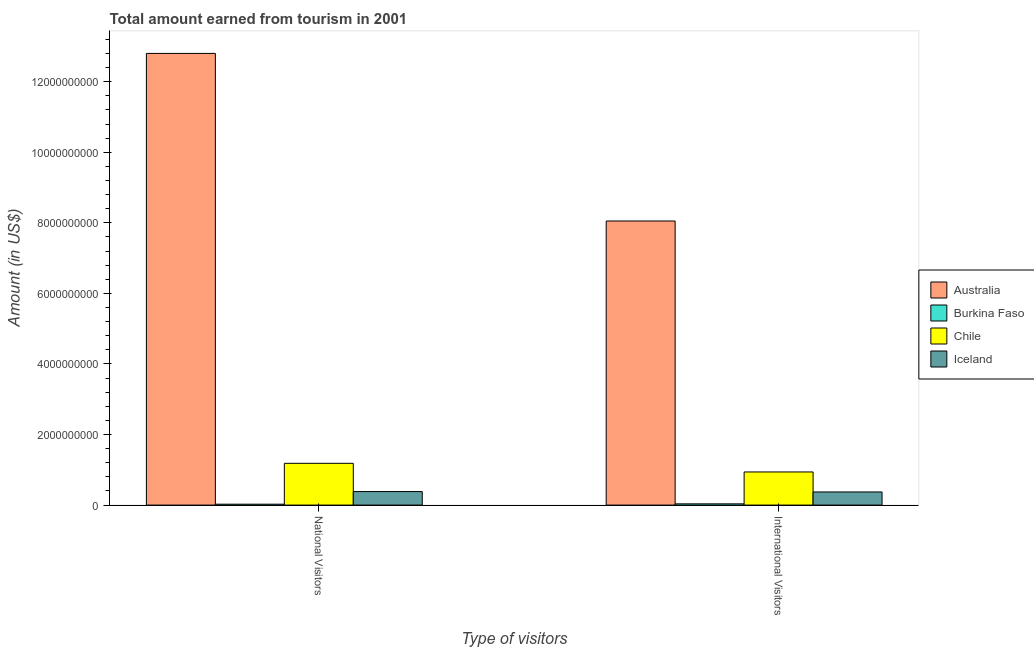Are the number of bars per tick equal to the number of legend labels?
Offer a very short reply. Yes. How many bars are there on the 1st tick from the right?
Give a very brief answer. 4. What is the label of the 1st group of bars from the left?
Keep it short and to the point. National Visitors. What is the amount earned from international visitors in Chile?
Provide a short and direct response. 9.39e+08. Across all countries, what is the maximum amount earned from international visitors?
Keep it short and to the point. 8.05e+09. Across all countries, what is the minimum amount earned from national visitors?
Offer a very short reply. 2.50e+07. In which country was the amount earned from national visitors maximum?
Make the answer very short. Australia. In which country was the amount earned from international visitors minimum?
Offer a very short reply. Burkina Faso. What is the total amount earned from national visitors in the graph?
Provide a short and direct response. 1.44e+1. What is the difference between the amount earned from national visitors in Iceland and that in Burkina Faso?
Offer a very short reply. 3.58e+08. What is the difference between the amount earned from national visitors in Iceland and the amount earned from international visitors in Australia?
Your answer should be compact. -7.67e+09. What is the average amount earned from national visitors per country?
Make the answer very short. 3.60e+09. What is the difference between the amount earned from international visitors and amount earned from national visitors in Chile?
Make the answer very short. -2.45e+08. In how many countries, is the amount earned from national visitors greater than 800000000 US$?
Your answer should be compact. 2. What is the ratio of the amount earned from national visitors in Australia to that in Iceland?
Offer a very short reply. 33.43. Is the amount earned from national visitors in Australia less than that in Iceland?
Make the answer very short. No. What does the 2nd bar from the left in National Visitors represents?
Offer a terse response. Burkina Faso. How many bars are there?
Ensure brevity in your answer.  8. How many countries are there in the graph?
Your answer should be very brief. 4. What is the difference between two consecutive major ticks on the Y-axis?
Give a very brief answer. 2.00e+09. Where does the legend appear in the graph?
Provide a succinct answer. Center right. How many legend labels are there?
Offer a very short reply. 4. What is the title of the graph?
Provide a short and direct response. Total amount earned from tourism in 2001. Does "Bangladesh" appear as one of the legend labels in the graph?
Provide a succinct answer. No. What is the label or title of the X-axis?
Provide a short and direct response. Type of visitors. What is the Amount (in US$) of Australia in National Visitors?
Your answer should be very brief. 1.28e+1. What is the Amount (in US$) of Burkina Faso in National Visitors?
Provide a succinct answer. 2.50e+07. What is the Amount (in US$) in Chile in National Visitors?
Your answer should be very brief. 1.18e+09. What is the Amount (in US$) of Iceland in National Visitors?
Offer a terse response. 3.83e+08. What is the Amount (in US$) in Australia in International Visitors?
Keep it short and to the point. 8.05e+09. What is the Amount (in US$) in Burkina Faso in International Visitors?
Your answer should be very brief. 3.50e+07. What is the Amount (in US$) in Chile in International Visitors?
Provide a succinct answer. 9.39e+08. What is the Amount (in US$) of Iceland in International Visitors?
Your answer should be compact. 3.72e+08. Across all Type of visitors, what is the maximum Amount (in US$) in Australia?
Give a very brief answer. 1.28e+1. Across all Type of visitors, what is the maximum Amount (in US$) in Burkina Faso?
Provide a succinct answer. 3.50e+07. Across all Type of visitors, what is the maximum Amount (in US$) in Chile?
Provide a short and direct response. 1.18e+09. Across all Type of visitors, what is the maximum Amount (in US$) of Iceland?
Offer a very short reply. 3.83e+08. Across all Type of visitors, what is the minimum Amount (in US$) in Australia?
Ensure brevity in your answer.  8.05e+09. Across all Type of visitors, what is the minimum Amount (in US$) of Burkina Faso?
Offer a terse response. 2.50e+07. Across all Type of visitors, what is the minimum Amount (in US$) of Chile?
Provide a short and direct response. 9.39e+08. Across all Type of visitors, what is the minimum Amount (in US$) in Iceland?
Your answer should be compact. 3.72e+08. What is the total Amount (in US$) in Australia in the graph?
Your answer should be compact. 2.09e+1. What is the total Amount (in US$) in Burkina Faso in the graph?
Keep it short and to the point. 6.00e+07. What is the total Amount (in US$) in Chile in the graph?
Your answer should be compact. 2.12e+09. What is the total Amount (in US$) of Iceland in the graph?
Ensure brevity in your answer.  7.55e+08. What is the difference between the Amount (in US$) in Australia in National Visitors and that in International Visitors?
Provide a succinct answer. 4.75e+09. What is the difference between the Amount (in US$) in Burkina Faso in National Visitors and that in International Visitors?
Give a very brief answer. -1.00e+07. What is the difference between the Amount (in US$) of Chile in National Visitors and that in International Visitors?
Offer a terse response. 2.45e+08. What is the difference between the Amount (in US$) in Iceland in National Visitors and that in International Visitors?
Keep it short and to the point. 1.10e+07. What is the difference between the Amount (in US$) in Australia in National Visitors and the Amount (in US$) in Burkina Faso in International Visitors?
Your answer should be very brief. 1.28e+1. What is the difference between the Amount (in US$) of Australia in National Visitors and the Amount (in US$) of Chile in International Visitors?
Your response must be concise. 1.19e+1. What is the difference between the Amount (in US$) of Australia in National Visitors and the Amount (in US$) of Iceland in International Visitors?
Ensure brevity in your answer.  1.24e+1. What is the difference between the Amount (in US$) in Burkina Faso in National Visitors and the Amount (in US$) in Chile in International Visitors?
Your response must be concise. -9.14e+08. What is the difference between the Amount (in US$) of Burkina Faso in National Visitors and the Amount (in US$) of Iceland in International Visitors?
Your answer should be compact. -3.47e+08. What is the difference between the Amount (in US$) in Chile in National Visitors and the Amount (in US$) in Iceland in International Visitors?
Ensure brevity in your answer.  8.12e+08. What is the average Amount (in US$) of Australia per Type of visitors?
Ensure brevity in your answer.  1.04e+1. What is the average Amount (in US$) of Burkina Faso per Type of visitors?
Your answer should be very brief. 3.00e+07. What is the average Amount (in US$) of Chile per Type of visitors?
Give a very brief answer. 1.06e+09. What is the average Amount (in US$) of Iceland per Type of visitors?
Your response must be concise. 3.78e+08. What is the difference between the Amount (in US$) in Australia and Amount (in US$) in Burkina Faso in National Visitors?
Provide a short and direct response. 1.28e+1. What is the difference between the Amount (in US$) in Australia and Amount (in US$) in Chile in National Visitors?
Your answer should be compact. 1.16e+1. What is the difference between the Amount (in US$) of Australia and Amount (in US$) of Iceland in National Visitors?
Your answer should be compact. 1.24e+1. What is the difference between the Amount (in US$) in Burkina Faso and Amount (in US$) in Chile in National Visitors?
Your answer should be compact. -1.16e+09. What is the difference between the Amount (in US$) of Burkina Faso and Amount (in US$) of Iceland in National Visitors?
Offer a very short reply. -3.58e+08. What is the difference between the Amount (in US$) of Chile and Amount (in US$) of Iceland in National Visitors?
Keep it short and to the point. 8.01e+08. What is the difference between the Amount (in US$) in Australia and Amount (in US$) in Burkina Faso in International Visitors?
Provide a short and direct response. 8.02e+09. What is the difference between the Amount (in US$) in Australia and Amount (in US$) in Chile in International Visitors?
Offer a very short reply. 7.11e+09. What is the difference between the Amount (in US$) in Australia and Amount (in US$) in Iceland in International Visitors?
Keep it short and to the point. 7.68e+09. What is the difference between the Amount (in US$) of Burkina Faso and Amount (in US$) of Chile in International Visitors?
Keep it short and to the point. -9.04e+08. What is the difference between the Amount (in US$) of Burkina Faso and Amount (in US$) of Iceland in International Visitors?
Offer a terse response. -3.37e+08. What is the difference between the Amount (in US$) of Chile and Amount (in US$) of Iceland in International Visitors?
Give a very brief answer. 5.67e+08. What is the ratio of the Amount (in US$) in Australia in National Visitors to that in International Visitors?
Keep it short and to the point. 1.59. What is the ratio of the Amount (in US$) in Chile in National Visitors to that in International Visitors?
Offer a terse response. 1.26. What is the ratio of the Amount (in US$) in Iceland in National Visitors to that in International Visitors?
Provide a succinct answer. 1.03. What is the difference between the highest and the second highest Amount (in US$) in Australia?
Your answer should be compact. 4.75e+09. What is the difference between the highest and the second highest Amount (in US$) in Burkina Faso?
Give a very brief answer. 1.00e+07. What is the difference between the highest and the second highest Amount (in US$) of Chile?
Give a very brief answer. 2.45e+08. What is the difference between the highest and the second highest Amount (in US$) of Iceland?
Offer a very short reply. 1.10e+07. What is the difference between the highest and the lowest Amount (in US$) in Australia?
Provide a short and direct response. 4.75e+09. What is the difference between the highest and the lowest Amount (in US$) in Burkina Faso?
Provide a succinct answer. 1.00e+07. What is the difference between the highest and the lowest Amount (in US$) of Chile?
Keep it short and to the point. 2.45e+08. What is the difference between the highest and the lowest Amount (in US$) in Iceland?
Give a very brief answer. 1.10e+07. 